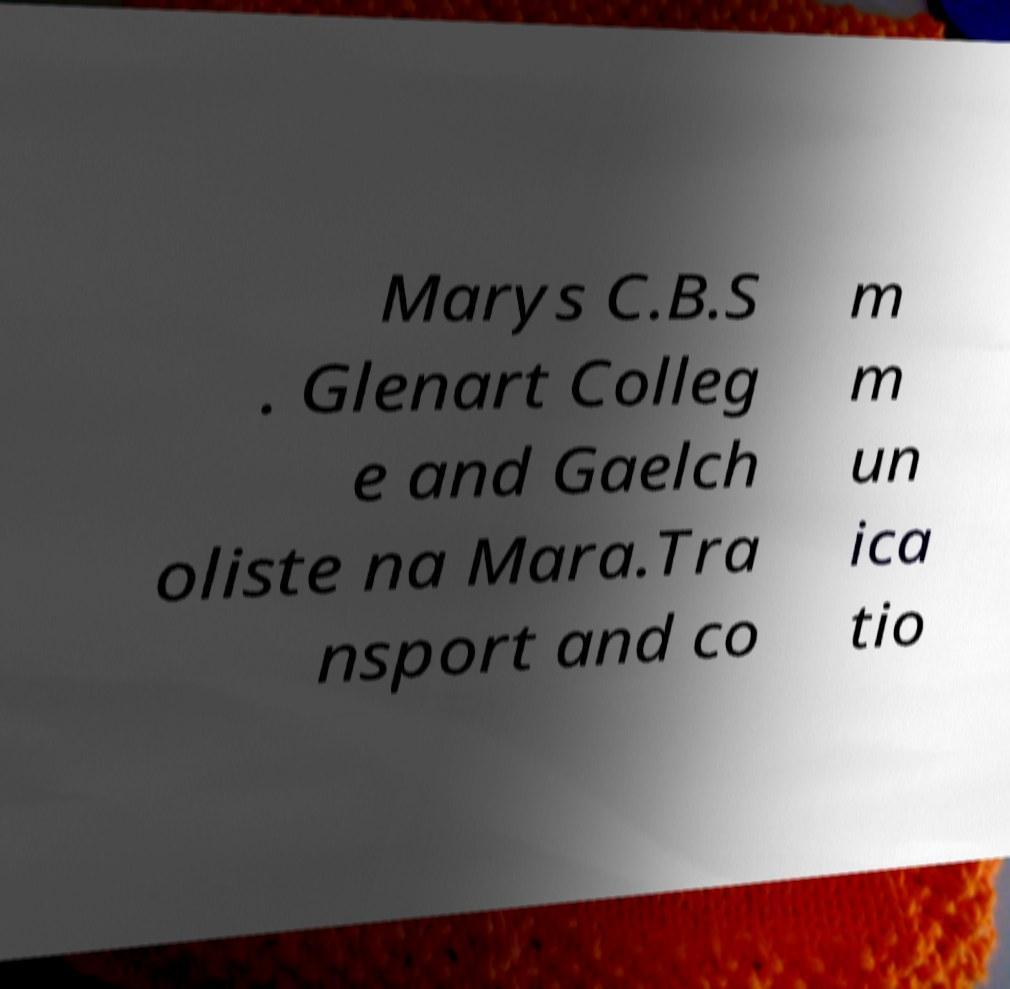Could you assist in decoding the text presented in this image and type it out clearly? Marys C.B.S . Glenart Colleg e and Gaelch oliste na Mara.Tra nsport and co m m un ica tio 